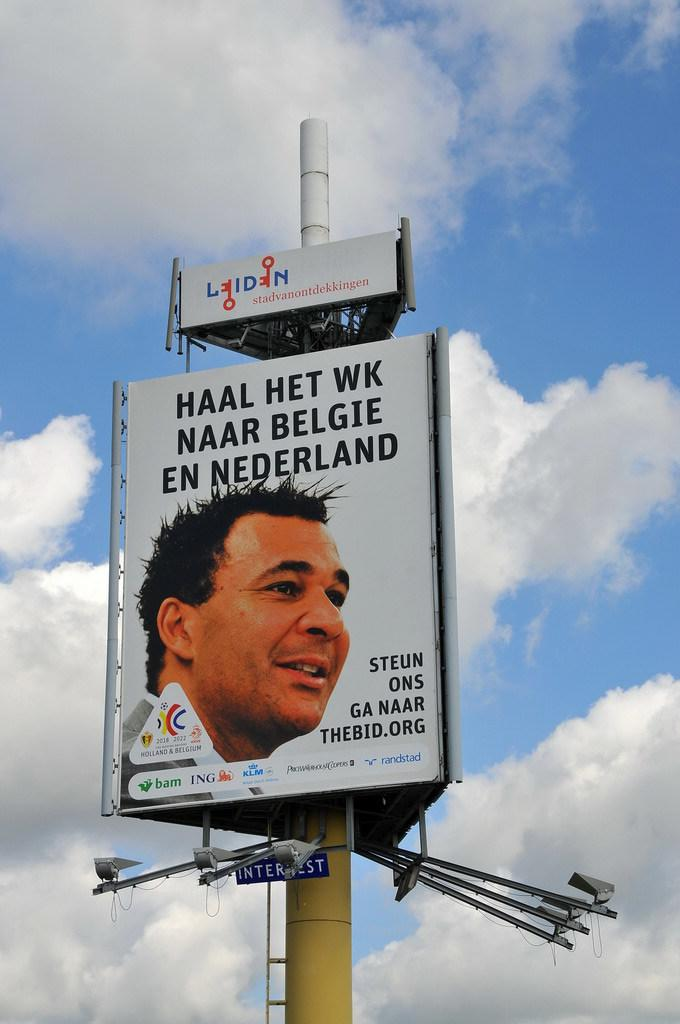<image>
Give a short and clear explanation of the subsequent image. A billboard with a person's face is sponsored by a number of companies including ING. 